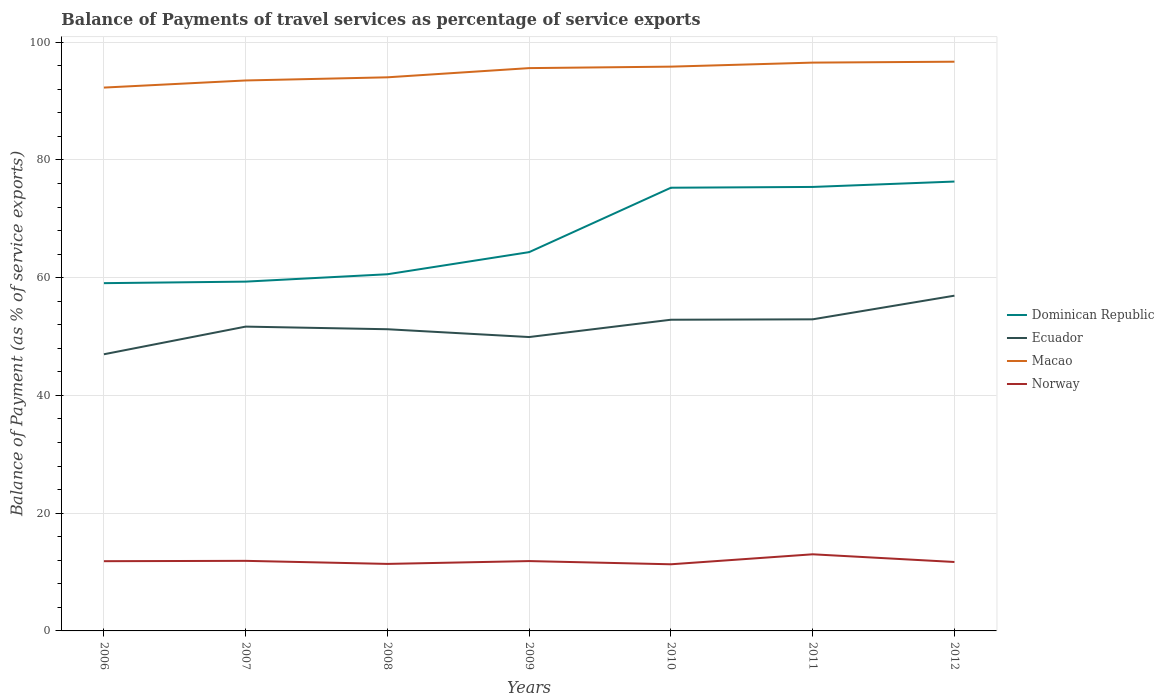Is the number of lines equal to the number of legend labels?
Offer a very short reply. Yes. Across all years, what is the maximum balance of payments of travel services in Macao?
Give a very brief answer. 92.29. What is the total balance of payments of travel services in Ecuador in the graph?
Keep it short and to the point. -5.25. What is the difference between the highest and the second highest balance of payments of travel services in Dominican Republic?
Your answer should be compact. 17.26. What is the difference between the highest and the lowest balance of payments of travel services in Norway?
Offer a very short reply. 3. Is the balance of payments of travel services in Ecuador strictly greater than the balance of payments of travel services in Dominican Republic over the years?
Ensure brevity in your answer.  Yes. How many years are there in the graph?
Make the answer very short. 7. Does the graph contain any zero values?
Make the answer very short. No. Where does the legend appear in the graph?
Your response must be concise. Center right. How many legend labels are there?
Your answer should be compact. 4. What is the title of the graph?
Your answer should be very brief. Balance of Payments of travel services as percentage of service exports. What is the label or title of the Y-axis?
Ensure brevity in your answer.  Balance of Payment (as % of service exports). What is the Balance of Payment (as % of service exports) in Dominican Republic in 2006?
Your answer should be very brief. 59.07. What is the Balance of Payment (as % of service exports) of Ecuador in 2006?
Offer a very short reply. 46.99. What is the Balance of Payment (as % of service exports) in Macao in 2006?
Make the answer very short. 92.29. What is the Balance of Payment (as % of service exports) of Norway in 2006?
Provide a short and direct response. 11.84. What is the Balance of Payment (as % of service exports) in Dominican Republic in 2007?
Ensure brevity in your answer.  59.33. What is the Balance of Payment (as % of service exports) of Ecuador in 2007?
Ensure brevity in your answer.  51.69. What is the Balance of Payment (as % of service exports) of Macao in 2007?
Make the answer very short. 93.5. What is the Balance of Payment (as % of service exports) in Norway in 2007?
Provide a short and direct response. 11.9. What is the Balance of Payment (as % of service exports) in Dominican Republic in 2008?
Provide a succinct answer. 60.58. What is the Balance of Payment (as % of service exports) in Ecuador in 2008?
Offer a terse response. 51.24. What is the Balance of Payment (as % of service exports) of Macao in 2008?
Provide a succinct answer. 94.03. What is the Balance of Payment (as % of service exports) in Norway in 2008?
Provide a short and direct response. 11.38. What is the Balance of Payment (as % of service exports) of Dominican Republic in 2009?
Offer a terse response. 64.34. What is the Balance of Payment (as % of service exports) of Ecuador in 2009?
Make the answer very short. 49.92. What is the Balance of Payment (as % of service exports) in Macao in 2009?
Offer a very short reply. 95.6. What is the Balance of Payment (as % of service exports) in Norway in 2009?
Provide a short and direct response. 11.86. What is the Balance of Payment (as % of service exports) in Dominican Republic in 2010?
Keep it short and to the point. 75.28. What is the Balance of Payment (as % of service exports) of Ecuador in 2010?
Provide a short and direct response. 52.86. What is the Balance of Payment (as % of service exports) of Macao in 2010?
Make the answer very short. 95.85. What is the Balance of Payment (as % of service exports) in Norway in 2010?
Your response must be concise. 11.32. What is the Balance of Payment (as % of service exports) of Dominican Republic in 2011?
Your response must be concise. 75.41. What is the Balance of Payment (as % of service exports) of Ecuador in 2011?
Give a very brief answer. 52.93. What is the Balance of Payment (as % of service exports) in Macao in 2011?
Make the answer very short. 96.53. What is the Balance of Payment (as % of service exports) of Norway in 2011?
Ensure brevity in your answer.  13.01. What is the Balance of Payment (as % of service exports) in Dominican Republic in 2012?
Give a very brief answer. 76.33. What is the Balance of Payment (as % of service exports) of Ecuador in 2012?
Give a very brief answer. 56.94. What is the Balance of Payment (as % of service exports) in Macao in 2012?
Your answer should be very brief. 96.68. What is the Balance of Payment (as % of service exports) in Norway in 2012?
Offer a very short reply. 11.71. Across all years, what is the maximum Balance of Payment (as % of service exports) in Dominican Republic?
Make the answer very short. 76.33. Across all years, what is the maximum Balance of Payment (as % of service exports) of Ecuador?
Your response must be concise. 56.94. Across all years, what is the maximum Balance of Payment (as % of service exports) in Macao?
Offer a very short reply. 96.68. Across all years, what is the maximum Balance of Payment (as % of service exports) in Norway?
Offer a terse response. 13.01. Across all years, what is the minimum Balance of Payment (as % of service exports) of Dominican Republic?
Ensure brevity in your answer.  59.07. Across all years, what is the minimum Balance of Payment (as % of service exports) in Ecuador?
Give a very brief answer. 46.99. Across all years, what is the minimum Balance of Payment (as % of service exports) of Macao?
Ensure brevity in your answer.  92.29. Across all years, what is the minimum Balance of Payment (as % of service exports) of Norway?
Your answer should be very brief. 11.32. What is the total Balance of Payment (as % of service exports) in Dominican Republic in the graph?
Keep it short and to the point. 470.34. What is the total Balance of Payment (as % of service exports) in Ecuador in the graph?
Ensure brevity in your answer.  362.57. What is the total Balance of Payment (as % of service exports) of Macao in the graph?
Your answer should be compact. 664.48. What is the total Balance of Payment (as % of service exports) in Norway in the graph?
Ensure brevity in your answer.  83.04. What is the difference between the Balance of Payment (as % of service exports) of Dominican Republic in 2006 and that in 2007?
Your answer should be very brief. -0.26. What is the difference between the Balance of Payment (as % of service exports) in Ecuador in 2006 and that in 2007?
Your answer should be compact. -4.7. What is the difference between the Balance of Payment (as % of service exports) in Macao in 2006 and that in 2007?
Your response must be concise. -1.21. What is the difference between the Balance of Payment (as % of service exports) of Norway in 2006 and that in 2007?
Ensure brevity in your answer.  -0.06. What is the difference between the Balance of Payment (as % of service exports) in Dominican Republic in 2006 and that in 2008?
Make the answer very short. -1.51. What is the difference between the Balance of Payment (as % of service exports) in Ecuador in 2006 and that in 2008?
Give a very brief answer. -4.25. What is the difference between the Balance of Payment (as % of service exports) of Macao in 2006 and that in 2008?
Provide a succinct answer. -1.74. What is the difference between the Balance of Payment (as % of service exports) of Norway in 2006 and that in 2008?
Ensure brevity in your answer.  0.46. What is the difference between the Balance of Payment (as % of service exports) of Dominican Republic in 2006 and that in 2009?
Your response must be concise. -5.27. What is the difference between the Balance of Payment (as % of service exports) in Ecuador in 2006 and that in 2009?
Offer a terse response. -2.92. What is the difference between the Balance of Payment (as % of service exports) of Macao in 2006 and that in 2009?
Provide a short and direct response. -3.31. What is the difference between the Balance of Payment (as % of service exports) in Norway in 2006 and that in 2009?
Give a very brief answer. -0.02. What is the difference between the Balance of Payment (as % of service exports) in Dominican Republic in 2006 and that in 2010?
Offer a very short reply. -16.21. What is the difference between the Balance of Payment (as % of service exports) in Ecuador in 2006 and that in 2010?
Your answer should be compact. -5.87. What is the difference between the Balance of Payment (as % of service exports) of Macao in 2006 and that in 2010?
Keep it short and to the point. -3.56. What is the difference between the Balance of Payment (as % of service exports) of Norway in 2006 and that in 2010?
Provide a succinct answer. 0.53. What is the difference between the Balance of Payment (as % of service exports) in Dominican Republic in 2006 and that in 2011?
Your answer should be compact. -16.34. What is the difference between the Balance of Payment (as % of service exports) in Ecuador in 2006 and that in 2011?
Make the answer very short. -5.94. What is the difference between the Balance of Payment (as % of service exports) of Macao in 2006 and that in 2011?
Your answer should be very brief. -4.24. What is the difference between the Balance of Payment (as % of service exports) of Norway in 2006 and that in 2011?
Keep it short and to the point. -1.17. What is the difference between the Balance of Payment (as % of service exports) in Dominican Republic in 2006 and that in 2012?
Offer a very short reply. -17.26. What is the difference between the Balance of Payment (as % of service exports) in Ecuador in 2006 and that in 2012?
Give a very brief answer. -9.95. What is the difference between the Balance of Payment (as % of service exports) of Macao in 2006 and that in 2012?
Provide a short and direct response. -4.4. What is the difference between the Balance of Payment (as % of service exports) in Norway in 2006 and that in 2012?
Provide a succinct answer. 0.13. What is the difference between the Balance of Payment (as % of service exports) of Dominican Republic in 2007 and that in 2008?
Offer a very short reply. -1.25. What is the difference between the Balance of Payment (as % of service exports) in Ecuador in 2007 and that in 2008?
Give a very brief answer. 0.45. What is the difference between the Balance of Payment (as % of service exports) in Macao in 2007 and that in 2008?
Your response must be concise. -0.53. What is the difference between the Balance of Payment (as % of service exports) in Norway in 2007 and that in 2008?
Offer a terse response. 0.52. What is the difference between the Balance of Payment (as % of service exports) in Dominican Republic in 2007 and that in 2009?
Provide a succinct answer. -5.01. What is the difference between the Balance of Payment (as % of service exports) in Ecuador in 2007 and that in 2009?
Ensure brevity in your answer.  1.77. What is the difference between the Balance of Payment (as % of service exports) of Macao in 2007 and that in 2009?
Provide a succinct answer. -2.1. What is the difference between the Balance of Payment (as % of service exports) of Norway in 2007 and that in 2009?
Offer a very short reply. 0.04. What is the difference between the Balance of Payment (as % of service exports) of Dominican Republic in 2007 and that in 2010?
Give a very brief answer. -15.95. What is the difference between the Balance of Payment (as % of service exports) of Ecuador in 2007 and that in 2010?
Your answer should be compact. -1.17. What is the difference between the Balance of Payment (as % of service exports) of Macao in 2007 and that in 2010?
Your answer should be very brief. -2.35. What is the difference between the Balance of Payment (as % of service exports) of Norway in 2007 and that in 2010?
Provide a succinct answer. 0.59. What is the difference between the Balance of Payment (as % of service exports) of Dominican Republic in 2007 and that in 2011?
Your answer should be very brief. -16.08. What is the difference between the Balance of Payment (as % of service exports) of Ecuador in 2007 and that in 2011?
Your response must be concise. -1.24. What is the difference between the Balance of Payment (as % of service exports) of Macao in 2007 and that in 2011?
Make the answer very short. -3.03. What is the difference between the Balance of Payment (as % of service exports) of Norway in 2007 and that in 2011?
Provide a short and direct response. -1.11. What is the difference between the Balance of Payment (as % of service exports) of Dominican Republic in 2007 and that in 2012?
Give a very brief answer. -17. What is the difference between the Balance of Payment (as % of service exports) in Ecuador in 2007 and that in 2012?
Provide a succinct answer. -5.25. What is the difference between the Balance of Payment (as % of service exports) of Macao in 2007 and that in 2012?
Provide a succinct answer. -3.19. What is the difference between the Balance of Payment (as % of service exports) in Norway in 2007 and that in 2012?
Ensure brevity in your answer.  0.19. What is the difference between the Balance of Payment (as % of service exports) of Dominican Republic in 2008 and that in 2009?
Offer a very short reply. -3.76. What is the difference between the Balance of Payment (as % of service exports) of Ecuador in 2008 and that in 2009?
Keep it short and to the point. 1.33. What is the difference between the Balance of Payment (as % of service exports) of Macao in 2008 and that in 2009?
Ensure brevity in your answer.  -1.56. What is the difference between the Balance of Payment (as % of service exports) in Norway in 2008 and that in 2009?
Keep it short and to the point. -0.48. What is the difference between the Balance of Payment (as % of service exports) in Dominican Republic in 2008 and that in 2010?
Give a very brief answer. -14.7. What is the difference between the Balance of Payment (as % of service exports) in Ecuador in 2008 and that in 2010?
Your answer should be compact. -1.61. What is the difference between the Balance of Payment (as % of service exports) in Macao in 2008 and that in 2010?
Provide a short and direct response. -1.81. What is the difference between the Balance of Payment (as % of service exports) of Norway in 2008 and that in 2010?
Your answer should be very brief. 0.07. What is the difference between the Balance of Payment (as % of service exports) of Dominican Republic in 2008 and that in 2011?
Offer a terse response. -14.83. What is the difference between the Balance of Payment (as % of service exports) in Ecuador in 2008 and that in 2011?
Give a very brief answer. -1.68. What is the difference between the Balance of Payment (as % of service exports) of Macao in 2008 and that in 2011?
Your response must be concise. -2.5. What is the difference between the Balance of Payment (as % of service exports) in Norway in 2008 and that in 2011?
Your answer should be compact. -1.63. What is the difference between the Balance of Payment (as % of service exports) in Dominican Republic in 2008 and that in 2012?
Keep it short and to the point. -15.75. What is the difference between the Balance of Payment (as % of service exports) of Ecuador in 2008 and that in 2012?
Offer a very short reply. -5.7. What is the difference between the Balance of Payment (as % of service exports) of Macao in 2008 and that in 2012?
Offer a very short reply. -2.65. What is the difference between the Balance of Payment (as % of service exports) of Norway in 2008 and that in 2012?
Ensure brevity in your answer.  -0.33. What is the difference between the Balance of Payment (as % of service exports) in Dominican Republic in 2009 and that in 2010?
Your answer should be very brief. -10.94. What is the difference between the Balance of Payment (as % of service exports) of Ecuador in 2009 and that in 2010?
Give a very brief answer. -2.94. What is the difference between the Balance of Payment (as % of service exports) of Macao in 2009 and that in 2010?
Provide a succinct answer. -0.25. What is the difference between the Balance of Payment (as % of service exports) of Norway in 2009 and that in 2010?
Your response must be concise. 0.54. What is the difference between the Balance of Payment (as % of service exports) in Dominican Republic in 2009 and that in 2011?
Ensure brevity in your answer.  -11.07. What is the difference between the Balance of Payment (as % of service exports) of Ecuador in 2009 and that in 2011?
Ensure brevity in your answer.  -3.01. What is the difference between the Balance of Payment (as % of service exports) of Macao in 2009 and that in 2011?
Your answer should be very brief. -0.93. What is the difference between the Balance of Payment (as % of service exports) in Norway in 2009 and that in 2011?
Offer a terse response. -1.15. What is the difference between the Balance of Payment (as % of service exports) of Dominican Republic in 2009 and that in 2012?
Provide a short and direct response. -11.99. What is the difference between the Balance of Payment (as % of service exports) in Ecuador in 2009 and that in 2012?
Provide a short and direct response. -7.03. What is the difference between the Balance of Payment (as % of service exports) in Macao in 2009 and that in 2012?
Give a very brief answer. -1.09. What is the difference between the Balance of Payment (as % of service exports) of Norway in 2009 and that in 2012?
Offer a terse response. 0.15. What is the difference between the Balance of Payment (as % of service exports) of Dominican Republic in 2010 and that in 2011?
Provide a succinct answer. -0.13. What is the difference between the Balance of Payment (as % of service exports) of Ecuador in 2010 and that in 2011?
Offer a terse response. -0.07. What is the difference between the Balance of Payment (as % of service exports) in Macao in 2010 and that in 2011?
Give a very brief answer. -0.68. What is the difference between the Balance of Payment (as % of service exports) of Norway in 2010 and that in 2011?
Provide a succinct answer. -1.7. What is the difference between the Balance of Payment (as % of service exports) of Dominican Republic in 2010 and that in 2012?
Make the answer very short. -1.05. What is the difference between the Balance of Payment (as % of service exports) in Ecuador in 2010 and that in 2012?
Ensure brevity in your answer.  -4.09. What is the difference between the Balance of Payment (as % of service exports) in Macao in 2010 and that in 2012?
Your response must be concise. -0.84. What is the difference between the Balance of Payment (as % of service exports) in Norway in 2010 and that in 2012?
Provide a succinct answer. -0.39. What is the difference between the Balance of Payment (as % of service exports) of Dominican Republic in 2011 and that in 2012?
Keep it short and to the point. -0.92. What is the difference between the Balance of Payment (as % of service exports) of Ecuador in 2011 and that in 2012?
Provide a short and direct response. -4.02. What is the difference between the Balance of Payment (as % of service exports) in Macao in 2011 and that in 2012?
Keep it short and to the point. -0.15. What is the difference between the Balance of Payment (as % of service exports) of Norway in 2011 and that in 2012?
Offer a terse response. 1.3. What is the difference between the Balance of Payment (as % of service exports) of Dominican Republic in 2006 and the Balance of Payment (as % of service exports) of Ecuador in 2007?
Ensure brevity in your answer.  7.38. What is the difference between the Balance of Payment (as % of service exports) in Dominican Republic in 2006 and the Balance of Payment (as % of service exports) in Macao in 2007?
Ensure brevity in your answer.  -34.43. What is the difference between the Balance of Payment (as % of service exports) in Dominican Republic in 2006 and the Balance of Payment (as % of service exports) in Norway in 2007?
Your answer should be compact. 47.16. What is the difference between the Balance of Payment (as % of service exports) of Ecuador in 2006 and the Balance of Payment (as % of service exports) of Macao in 2007?
Ensure brevity in your answer.  -46.51. What is the difference between the Balance of Payment (as % of service exports) of Ecuador in 2006 and the Balance of Payment (as % of service exports) of Norway in 2007?
Keep it short and to the point. 35.09. What is the difference between the Balance of Payment (as % of service exports) in Macao in 2006 and the Balance of Payment (as % of service exports) in Norway in 2007?
Your answer should be very brief. 80.39. What is the difference between the Balance of Payment (as % of service exports) in Dominican Republic in 2006 and the Balance of Payment (as % of service exports) in Ecuador in 2008?
Provide a succinct answer. 7.83. What is the difference between the Balance of Payment (as % of service exports) of Dominican Republic in 2006 and the Balance of Payment (as % of service exports) of Macao in 2008?
Keep it short and to the point. -34.96. What is the difference between the Balance of Payment (as % of service exports) of Dominican Republic in 2006 and the Balance of Payment (as % of service exports) of Norway in 2008?
Ensure brevity in your answer.  47.68. What is the difference between the Balance of Payment (as % of service exports) in Ecuador in 2006 and the Balance of Payment (as % of service exports) in Macao in 2008?
Provide a succinct answer. -47.04. What is the difference between the Balance of Payment (as % of service exports) of Ecuador in 2006 and the Balance of Payment (as % of service exports) of Norway in 2008?
Give a very brief answer. 35.61. What is the difference between the Balance of Payment (as % of service exports) of Macao in 2006 and the Balance of Payment (as % of service exports) of Norway in 2008?
Your answer should be very brief. 80.91. What is the difference between the Balance of Payment (as % of service exports) of Dominican Republic in 2006 and the Balance of Payment (as % of service exports) of Ecuador in 2009?
Offer a very short reply. 9.15. What is the difference between the Balance of Payment (as % of service exports) of Dominican Republic in 2006 and the Balance of Payment (as % of service exports) of Macao in 2009?
Make the answer very short. -36.53. What is the difference between the Balance of Payment (as % of service exports) of Dominican Republic in 2006 and the Balance of Payment (as % of service exports) of Norway in 2009?
Provide a short and direct response. 47.21. What is the difference between the Balance of Payment (as % of service exports) of Ecuador in 2006 and the Balance of Payment (as % of service exports) of Macao in 2009?
Make the answer very short. -48.61. What is the difference between the Balance of Payment (as % of service exports) in Ecuador in 2006 and the Balance of Payment (as % of service exports) in Norway in 2009?
Offer a terse response. 35.13. What is the difference between the Balance of Payment (as % of service exports) of Macao in 2006 and the Balance of Payment (as % of service exports) of Norway in 2009?
Make the answer very short. 80.43. What is the difference between the Balance of Payment (as % of service exports) in Dominican Republic in 2006 and the Balance of Payment (as % of service exports) in Ecuador in 2010?
Give a very brief answer. 6.21. What is the difference between the Balance of Payment (as % of service exports) in Dominican Republic in 2006 and the Balance of Payment (as % of service exports) in Macao in 2010?
Your answer should be very brief. -36.78. What is the difference between the Balance of Payment (as % of service exports) in Dominican Republic in 2006 and the Balance of Payment (as % of service exports) in Norway in 2010?
Make the answer very short. 47.75. What is the difference between the Balance of Payment (as % of service exports) of Ecuador in 2006 and the Balance of Payment (as % of service exports) of Macao in 2010?
Offer a very short reply. -48.85. What is the difference between the Balance of Payment (as % of service exports) in Ecuador in 2006 and the Balance of Payment (as % of service exports) in Norway in 2010?
Keep it short and to the point. 35.67. What is the difference between the Balance of Payment (as % of service exports) of Macao in 2006 and the Balance of Payment (as % of service exports) of Norway in 2010?
Make the answer very short. 80.97. What is the difference between the Balance of Payment (as % of service exports) in Dominican Republic in 2006 and the Balance of Payment (as % of service exports) in Ecuador in 2011?
Make the answer very short. 6.14. What is the difference between the Balance of Payment (as % of service exports) of Dominican Republic in 2006 and the Balance of Payment (as % of service exports) of Macao in 2011?
Provide a short and direct response. -37.46. What is the difference between the Balance of Payment (as % of service exports) of Dominican Republic in 2006 and the Balance of Payment (as % of service exports) of Norway in 2011?
Keep it short and to the point. 46.05. What is the difference between the Balance of Payment (as % of service exports) of Ecuador in 2006 and the Balance of Payment (as % of service exports) of Macao in 2011?
Your answer should be compact. -49.54. What is the difference between the Balance of Payment (as % of service exports) of Ecuador in 2006 and the Balance of Payment (as % of service exports) of Norway in 2011?
Provide a short and direct response. 33.98. What is the difference between the Balance of Payment (as % of service exports) of Macao in 2006 and the Balance of Payment (as % of service exports) of Norway in 2011?
Provide a short and direct response. 79.27. What is the difference between the Balance of Payment (as % of service exports) in Dominican Republic in 2006 and the Balance of Payment (as % of service exports) in Ecuador in 2012?
Give a very brief answer. 2.12. What is the difference between the Balance of Payment (as % of service exports) of Dominican Republic in 2006 and the Balance of Payment (as % of service exports) of Macao in 2012?
Your answer should be compact. -37.62. What is the difference between the Balance of Payment (as % of service exports) in Dominican Republic in 2006 and the Balance of Payment (as % of service exports) in Norway in 2012?
Your answer should be compact. 47.36. What is the difference between the Balance of Payment (as % of service exports) in Ecuador in 2006 and the Balance of Payment (as % of service exports) in Macao in 2012?
Your answer should be compact. -49.69. What is the difference between the Balance of Payment (as % of service exports) in Ecuador in 2006 and the Balance of Payment (as % of service exports) in Norway in 2012?
Offer a terse response. 35.28. What is the difference between the Balance of Payment (as % of service exports) in Macao in 2006 and the Balance of Payment (as % of service exports) in Norway in 2012?
Make the answer very short. 80.58. What is the difference between the Balance of Payment (as % of service exports) in Dominican Republic in 2007 and the Balance of Payment (as % of service exports) in Ecuador in 2008?
Your response must be concise. 8.09. What is the difference between the Balance of Payment (as % of service exports) in Dominican Republic in 2007 and the Balance of Payment (as % of service exports) in Macao in 2008?
Give a very brief answer. -34.7. What is the difference between the Balance of Payment (as % of service exports) of Dominican Republic in 2007 and the Balance of Payment (as % of service exports) of Norway in 2008?
Your answer should be very brief. 47.94. What is the difference between the Balance of Payment (as % of service exports) in Ecuador in 2007 and the Balance of Payment (as % of service exports) in Macao in 2008?
Ensure brevity in your answer.  -42.34. What is the difference between the Balance of Payment (as % of service exports) of Ecuador in 2007 and the Balance of Payment (as % of service exports) of Norway in 2008?
Offer a terse response. 40.31. What is the difference between the Balance of Payment (as % of service exports) of Macao in 2007 and the Balance of Payment (as % of service exports) of Norway in 2008?
Provide a succinct answer. 82.11. What is the difference between the Balance of Payment (as % of service exports) of Dominican Republic in 2007 and the Balance of Payment (as % of service exports) of Ecuador in 2009?
Make the answer very short. 9.41. What is the difference between the Balance of Payment (as % of service exports) in Dominican Republic in 2007 and the Balance of Payment (as % of service exports) in Macao in 2009?
Your response must be concise. -36.27. What is the difference between the Balance of Payment (as % of service exports) in Dominican Republic in 2007 and the Balance of Payment (as % of service exports) in Norway in 2009?
Your response must be concise. 47.47. What is the difference between the Balance of Payment (as % of service exports) in Ecuador in 2007 and the Balance of Payment (as % of service exports) in Macao in 2009?
Your response must be concise. -43.91. What is the difference between the Balance of Payment (as % of service exports) of Ecuador in 2007 and the Balance of Payment (as % of service exports) of Norway in 2009?
Keep it short and to the point. 39.83. What is the difference between the Balance of Payment (as % of service exports) of Macao in 2007 and the Balance of Payment (as % of service exports) of Norway in 2009?
Keep it short and to the point. 81.63. What is the difference between the Balance of Payment (as % of service exports) of Dominican Republic in 2007 and the Balance of Payment (as % of service exports) of Ecuador in 2010?
Offer a terse response. 6.47. What is the difference between the Balance of Payment (as % of service exports) of Dominican Republic in 2007 and the Balance of Payment (as % of service exports) of Macao in 2010?
Ensure brevity in your answer.  -36.52. What is the difference between the Balance of Payment (as % of service exports) of Dominican Republic in 2007 and the Balance of Payment (as % of service exports) of Norway in 2010?
Offer a very short reply. 48.01. What is the difference between the Balance of Payment (as % of service exports) in Ecuador in 2007 and the Balance of Payment (as % of service exports) in Macao in 2010?
Provide a succinct answer. -44.16. What is the difference between the Balance of Payment (as % of service exports) in Ecuador in 2007 and the Balance of Payment (as % of service exports) in Norway in 2010?
Your answer should be compact. 40.37. What is the difference between the Balance of Payment (as % of service exports) of Macao in 2007 and the Balance of Payment (as % of service exports) of Norway in 2010?
Give a very brief answer. 82.18. What is the difference between the Balance of Payment (as % of service exports) in Dominican Republic in 2007 and the Balance of Payment (as % of service exports) in Ecuador in 2011?
Your response must be concise. 6.4. What is the difference between the Balance of Payment (as % of service exports) in Dominican Republic in 2007 and the Balance of Payment (as % of service exports) in Macao in 2011?
Give a very brief answer. -37.2. What is the difference between the Balance of Payment (as % of service exports) of Dominican Republic in 2007 and the Balance of Payment (as % of service exports) of Norway in 2011?
Your answer should be compact. 46.31. What is the difference between the Balance of Payment (as % of service exports) in Ecuador in 2007 and the Balance of Payment (as % of service exports) in Macao in 2011?
Offer a terse response. -44.84. What is the difference between the Balance of Payment (as % of service exports) in Ecuador in 2007 and the Balance of Payment (as % of service exports) in Norway in 2011?
Give a very brief answer. 38.68. What is the difference between the Balance of Payment (as % of service exports) in Macao in 2007 and the Balance of Payment (as % of service exports) in Norway in 2011?
Provide a short and direct response. 80.48. What is the difference between the Balance of Payment (as % of service exports) of Dominican Republic in 2007 and the Balance of Payment (as % of service exports) of Ecuador in 2012?
Give a very brief answer. 2.38. What is the difference between the Balance of Payment (as % of service exports) in Dominican Republic in 2007 and the Balance of Payment (as % of service exports) in Macao in 2012?
Keep it short and to the point. -37.36. What is the difference between the Balance of Payment (as % of service exports) of Dominican Republic in 2007 and the Balance of Payment (as % of service exports) of Norway in 2012?
Make the answer very short. 47.62. What is the difference between the Balance of Payment (as % of service exports) of Ecuador in 2007 and the Balance of Payment (as % of service exports) of Macao in 2012?
Offer a very short reply. -44.99. What is the difference between the Balance of Payment (as % of service exports) in Ecuador in 2007 and the Balance of Payment (as % of service exports) in Norway in 2012?
Make the answer very short. 39.98. What is the difference between the Balance of Payment (as % of service exports) in Macao in 2007 and the Balance of Payment (as % of service exports) in Norway in 2012?
Ensure brevity in your answer.  81.79. What is the difference between the Balance of Payment (as % of service exports) in Dominican Republic in 2008 and the Balance of Payment (as % of service exports) in Ecuador in 2009?
Offer a very short reply. 10.67. What is the difference between the Balance of Payment (as % of service exports) of Dominican Republic in 2008 and the Balance of Payment (as % of service exports) of Macao in 2009?
Provide a short and direct response. -35.01. What is the difference between the Balance of Payment (as % of service exports) of Dominican Republic in 2008 and the Balance of Payment (as % of service exports) of Norway in 2009?
Keep it short and to the point. 48.72. What is the difference between the Balance of Payment (as % of service exports) of Ecuador in 2008 and the Balance of Payment (as % of service exports) of Macao in 2009?
Give a very brief answer. -44.35. What is the difference between the Balance of Payment (as % of service exports) of Ecuador in 2008 and the Balance of Payment (as % of service exports) of Norway in 2009?
Give a very brief answer. 39.38. What is the difference between the Balance of Payment (as % of service exports) in Macao in 2008 and the Balance of Payment (as % of service exports) in Norway in 2009?
Your answer should be very brief. 82.17. What is the difference between the Balance of Payment (as % of service exports) in Dominican Republic in 2008 and the Balance of Payment (as % of service exports) in Ecuador in 2010?
Ensure brevity in your answer.  7.73. What is the difference between the Balance of Payment (as % of service exports) in Dominican Republic in 2008 and the Balance of Payment (as % of service exports) in Macao in 2010?
Give a very brief answer. -35.26. What is the difference between the Balance of Payment (as % of service exports) in Dominican Republic in 2008 and the Balance of Payment (as % of service exports) in Norway in 2010?
Offer a terse response. 49.26. What is the difference between the Balance of Payment (as % of service exports) of Ecuador in 2008 and the Balance of Payment (as % of service exports) of Macao in 2010?
Ensure brevity in your answer.  -44.6. What is the difference between the Balance of Payment (as % of service exports) in Ecuador in 2008 and the Balance of Payment (as % of service exports) in Norway in 2010?
Your answer should be very brief. 39.92. What is the difference between the Balance of Payment (as % of service exports) of Macao in 2008 and the Balance of Payment (as % of service exports) of Norway in 2010?
Ensure brevity in your answer.  82.71. What is the difference between the Balance of Payment (as % of service exports) of Dominican Republic in 2008 and the Balance of Payment (as % of service exports) of Ecuador in 2011?
Provide a succinct answer. 7.66. What is the difference between the Balance of Payment (as % of service exports) in Dominican Republic in 2008 and the Balance of Payment (as % of service exports) in Macao in 2011?
Your response must be concise. -35.95. What is the difference between the Balance of Payment (as % of service exports) in Dominican Republic in 2008 and the Balance of Payment (as % of service exports) in Norway in 2011?
Make the answer very short. 47.57. What is the difference between the Balance of Payment (as % of service exports) of Ecuador in 2008 and the Balance of Payment (as % of service exports) of Macao in 2011?
Ensure brevity in your answer.  -45.29. What is the difference between the Balance of Payment (as % of service exports) in Ecuador in 2008 and the Balance of Payment (as % of service exports) in Norway in 2011?
Offer a terse response. 38.23. What is the difference between the Balance of Payment (as % of service exports) in Macao in 2008 and the Balance of Payment (as % of service exports) in Norway in 2011?
Provide a succinct answer. 81.02. What is the difference between the Balance of Payment (as % of service exports) in Dominican Republic in 2008 and the Balance of Payment (as % of service exports) in Ecuador in 2012?
Ensure brevity in your answer.  3.64. What is the difference between the Balance of Payment (as % of service exports) of Dominican Republic in 2008 and the Balance of Payment (as % of service exports) of Macao in 2012?
Provide a succinct answer. -36.1. What is the difference between the Balance of Payment (as % of service exports) in Dominican Republic in 2008 and the Balance of Payment (as % of service exports) in Norway in 2012?
Your response must be concise. 48.87. What is the difference between the Balance of Payment (as % of service exports) of Ecuador in 2008 and the Balance of Payment (as % of service exports) of Macao in 2012?
Provide a succinct answer. -45.44. What is the difference between the Balance of Payment (as % of service exports) in Ecuador in 2008 and the Balance of Payment (as % of service exports) in Norway in 2012?
Provide a short and direct response. 39.53. What is the difference between the Balance of Payment (as % of service exports) of Macao in 2008 and the Balance of Payment (as % of service exports) of Norway in 2012?
Offer a very short reply. 82.32. What is the difference between the Balance of Payment (as % of service exports) in Dominican Republic in 2009 and the Balance of Payment (as % of service exports) in Ecuador in 2010?
Offer a very short reply. 11.48. What is the difference between the Balance of Payment (as % of service exports) in Dominican Republic in 2009 and the Balance of Payment (as % of service exports) in Macao in 2010?
Keep it short and to the point. -31.51. What is the difference between the Balance of Payment (as % of service exports) of Dominican Republic in 2009 and the Balance of Payment (as % of service exports) of Norway in 2010?
Make the answer very short. 53.02. What is the difference between the Balance of Payment (as % of service exports) in Ecuador in 2009 and the Balance of Payment (as % of service exports) in Macao in 2010?
Your response must be concise. -45.93. What is the difference between the Balance of Payment (as % of service exports) of Ecuador in 2009 and the Balance of Payment (as % of service exports) of Norway in 2010?
Your answer should be very brief. 38.6. What is the difference between the Balance of Payment (as % of service exports) of Macao in 2009 and the Balance of Payment (as % of service exports) of Norway in 2010?
Your response must be concise. 84.28. What is the difference between the Balance of Payment (as % of service exports) of Dominican Republic in 2009 and the Balance of Payment (as % of service exports) of Ecuador in 2011?
Provide a short and direct response. 11.41. What is the difference between the Balance of Payment (as % of service exports) in Dominican Republic in 2009 and the Balance of Payment (as % of service exports) in Macao in 2011?
Offer a very short reply. -32.19. What is the difference between the Balance of Payment (as % of service exports) of Dominican Republic in 2009 and the Balance of Payment (as % of service exports) of Norway in 2011?
Ensure brevity in your answer.  51.33. What is the difference between the Balance of Payment (as % of service exports) in Ecuador in 2009 and the Balance of Payment (as % of service exports) in Macao in 2011?
Your response must be concise. -46.61. What is the difference between the Balance of Payment (as % of service exports) in Ecuador in 2009 and the Balance of Payment (as % of service exports) in Norway in 2011?
Keep it short and to the point. 36.9. What is the difference between the Balance of Payment (as % of service exports) in Macao in 2009 and the Balance of Payment (as % of service exports) in Norway in 2011?
Offer a very short reply. 82.58. What is the difference between the Balance of Payment (as % of service exports) of Dominican Republic in 2009 and the Balance of Payment (as % of service exports) of Ecuador in 2012?
Your answer should be compact. 7.4. What is the difference between the Balance of Payment (as % of service exports) in Dominican Republic in 2009 and the Balance of Payment (as % of service exports) in Macao in 2012?
Provide a short and direct response. -32.34. What is the difference between the Balance of Payment (as % of service exports) of Dominican Republic in 2009 and the Balance of Payment (as % of service exports) of Norway in 2012?
Your answer should be very brief. 52.63. What is the difference between the Balance of Payment (as % of service exports) of Ecuador in 2009 and the Balance of Payment (as % of service exports) of Macao in 2012?
Ensure brevity in your answer.  -46.77. What is the difference between the Balance of Payment (as % of service exports) of Ecuador in 2009 and the Balance of Payment (as % of service exports) of Norway in 2012?
Provide a succinct answer. 38.21. What is the difference between the Balance of Payment (as % of service exports) in Macao in 2009 and the Balance of Payment (as % of service exports) in Norway in 2012?
Provide a short and direct response. 83.89. What is the difference between the Balance of Payment (as % of service exports) in Dominican Republic in 2010 and the Balance of Payment (as % of service exports) in Ecuador in 2011?
Your response must be concise. 22.35. What is the difference between the Balance of Payment (as % of service exports) of Dominican Republic in 2010 and the Balance of Payment (as % of service exports) of Macao in 2011?
Provide a short and direct response. -21.25. What is the difference between the Balance of Payment (as % of service exports) of Dominican Republic in 2010 and the Balance of Payment (as % of service exports) of Norway in 2011?
Ensure brevity in your answer.  62.27. What is the difference between the Balance of Payment (as % of service exports) of Ecuador in 2010 and the Balance of Payment (as % of service exports) of Macao in 2011?
Offer a terse response. -43.67. What is the difference between the Balance of Payment (as % of service exports) of Ecuador in 2010 and the Balance of Payment (as % of service exports) of Norway in 2011?
Your answer should be compact. 39.84. What is the difference between the Balance of Payment (as % of service exports) in Macao in 2010 and the Balance of Payment (as % of service exports) in Norway in 2011?
Your answer should be very brief. 82.83. What is the difference between the Balance of Payment (as % of service exports) in Dominican Republic in 2010 and the Balance of Payment (as % of service exports) in Ecuador in 2012?
Ensure brevity in your answer.  18.34. What is the difference between the Balance of Payment (as % of service exports) in Dominican Republic in 2010 and the Balance of Payment (as % of service exports) in Macao in 2012?
Give a very brief answer. -21.4. What is the difference between the Balance of Payment (as % of service exports) of Dominican Republic in 2010 and the Balance of Payment (as % of service exports) of Norway in 2012?
Give a very brief answer. 63.57. What is the difference between the Balance of Payment (as % of service exports) of Ecuador in 2010 and the Balance of Payment (as % of service exports) of Macao in 2012?
Your response must be concise. -43.83. What is the difference between the Balance of Payment (as % of service exports) in Ecuador in 2010 and the Balance of Payment (as % of service exports) in Norway in 2012?
Your response must be concise. 41.15. What is the difference between the Balance of Payment (as % of service exports) in Macao in 2010 and the Balance of Payment (as % of service exports) in Norway in 2012?
Give a very brief answer. 84.14. What is the difference between the Balance of Payment (as % of service exports) in Dominican Republic in 2011 and the Balance of Payment (as % of service exports) in Ecuador in 2012?
Keep it short and to the point. 18.47. What is the difference between the Balance of Payment (as % of service exports) in Dominican Republic in 2011 and the Balance of Payment (as % of service exports) in Macao in 2012?
Offer a terse response. -21.27. What is the difference between the Balance of Payment (as % of service exports) of Dominican Republic in 2011 and the Balance of Payment (as % of service exports) of Norway in 2012?
Ensure brevity in your answer.  63.7. What is the difference between the Balance of Payment (as % of service exports) of Ecuador in 2011 and the Balance of Payment (as % of service exports) of Macao in 2012?
Your answer should be compact. -43.76. What is the difference between the Balance of Payment (as % of service exports) of Ecuador in 2011 and the Balance of Payment (as % of service exports) of Norway in 2012?
Offer a terse response. 41.22. What is the difference between the Balance of Payment (as % of service exports) in Macao in 2011 and the Balance of Payment (as % of service exports) in Norway in 2012?
Your answer should be compact. 84.82. What is the average Balance of Payment (as % of service exports) in Dominican Republic per year?
Make the answer very short. 67.19. What is the average Balance of Payment (as % of service exports) in Ecuador per year?
Provide a succinct answer. 51.8. What is the average Balance of Payment (as % of service exports) in Macao per year?
Offer a very short reply. 94.93. What is the average Balance of Payment (as % of service exports) of Norway per year?
Keep it short and to the point. 11.86. In the year 2006, what is the difference between the Balance of Payment (as % of service exports) of Dominican Republic and Balance of Payment (as % of service exports) of Ecuador?
Keep it short and to the point. 12.08. In the year 2006, what is the difference between the Balance of Payment (as % of service exports) in Dominican Republic and Balance of Payment (as % of service exports) in Macao?
Keep it short and to the point. -33.22. In the year 2006, what is the difference between the Balance of Payment (as % of service exports) in Dominican Republic and Balance of Payment (as % of service exports) in Norway?
Offer a very short reply. 47.22. In the year 2006, what is the difference between the Balance of Payment (as % of service exports) in Ecuador and Balance of Payment (as % of service exports) in Macao?
Offer a terse response. -45.3. In the year 2006, what is the difference between the Balance of Payment (as % of service exports) in Ecuador and Balance of Payment (as % of service exports) in Norway?
Your answer should be compact. 35.15. In the year 2006, what is the difference between the Balance of Payment (as % of service exports) in Macao and Balance of Payment (as % of service exports) in Norway?
Provide a short and direct response. 80.44. In the year 2007, what is the difference between the Balance of Payment (as % of service exports) of Dominican Republic and Balance of Payment (as % of service exports) of Ecuador?
Your answer should be very brief. 7.64. In the year 2007, what is the difference between the Balance of Payment (as % of service exports) of Dominican Republic and Balance of Payment (as % of service exports) of Macao?
Offer a terse response. -34.17. In the year 2007, what is the difference between the Balance of Payment (as % of service exports) in Dominican Republic and Balance of Payment (as % of service exports) in Norway?
Your response must be concise. 47.42. In the year 2007, what is the difference between the Balance of Payment (as % of service exports) in Ecuador and Balance of Payment (as % of service exports) in Macao?
Ensure brevity in your answer.  -41.81. In the year 2007, what is the difference between the Balance of Payment (as % of service exports) in Ecuador and Balance of Payment (as % of service exports) in Norway?
Your response must be concise. 39.79. In the year 2007, what is the difference between the Balance of Payment (as % of service exports) of Macao and Balance of Payment (as % of service exports) of Norway?
Give a very brief answer. 81.59. In the year 2008, what is the difference between the Balance of Payment (as % of service exports) of Dominican Republic and Balance of Payment (as % of service exports) of Ecuador?
Your response must be concise. 9.34. In the year 2008, what is the difference between the Balance of Payment (as % of service exports) in Dominican Republic and Balance of Payment (as % of service exports) in Macao?
Your response must be concise. -33.45. In the year 2008, what is the difference between the Balance of Payment (as % of service exports) of Dominican Republic and Balance of Payment (as % of service exports) of Norway?
Offer a terse response. 49.2. In the year 2008, what is the difference between the Balance of Payment (as % of service exports) in Ecuador and Balance of Payment (as % of service exports) in Macao?
Ensure brevity in your answer.  -42.79. In the year 2008, what is the difference between the Balance of Payment (as % of service exports) in Ecuador and Balance of Payment (as % of service exports) in Norway?
Your answer should be compact. 39.86. In the year 2008, what is the difference between the Balance of Payment (as % of service exports) of Macao and Balance of Payment (as % of service exports) of Norway?
Your response must be concise. 82.65. In the year 2009, what is the difference between the Balance of Payment (as % of service exports) in Dominican Republic and Balance of Payment (as % of service exports) in Ecuador?
Your response must be concise. 14.42. In the year 2009, what is the difference between the Balance of Payment (as % of service exports) in Dominican Republic and Balance of Payment (as % of service exports) in Macao?
Your response must be concise. -31.26. In the year 2009, what is the difference between the Balance of Payment (as % of service exports) of Dominican Republic and Balance of Payment (as % of service exports) of Norway?
Your response must be concise. 52.48. In the year 2009, what is the difference between the Balance of Payment (as % of service exports) of Ecuador and Balance of Payment (as % of service exports) of Macao?
Provide a short and direct response. -45.68. In the year 2009, what is the difference between the Balance of Payment (as % of service exports) of Ecuador and Balance of Payment (as % of service exports) of Norway?
Offer a very short reply. 38.05. In the year 2009, what is the difference between the Balance of Payment (as % of service exports) of Macao and Balance of Payment (as % of service exports) of Norway?
Your response must be concise. 83.73. In the year 2010, what is the difference between the Balance of Payment (as % of service exports) of Dominican Republic and Balance of Payment (as % of service exports) of Ecuador?
Ensure brevity in your answer.  22.42. In the year 2010, what is the difference between the Balance of Payment (as % of service exports) in Dominican Republic and Balance of Payment (as % of service exports) in Macao?
Give a very brief answer. -20.57. In the year 2010, what is the difference between the Balance of Payment (as % of service exports) in Dominican Republic and Balance of Payment (as % of service exports) in Norway?
Offer a terse response. 63.96. In the year 2010, what is the difference between the Balance of Payment (as % of service exports) of Ecuador and Balance of Payment (as % of service exports) of Macao?
Your response must be concise. -42.99. In the year 2010, what is the difference between the Balance of Payment (as % of service exports) in Ecuador and Balance of Payment (as % of service exports) in Norway?
Your answer should be very brief. 41.54. In the year 2010, what is the difference between the Balance of Payment (as % of service exports) of Macao and Balance of Payment (as % of service exports) of Norway?
Offer a terse response. 84.53. In the year 2011, what is the difference between the Balance of Payment (as % of service exports) in Dominican Republic and Balance of Payment (as % of service exports) in Ecuador?
Offer a terse response. 22.48. In the year 2011, what is the difference between the Balance of Payment (as % of service exports) of Dominican Republic and Balance of Payment (as % of service exports) of Macao?
Offer a very short reply. -21.12. In the year 2011, what is the difference between the Balance of Payment (as % of service exports) of Dominican Republic and Balance of Payment (as % of service exports) of Norway?
Provide a short and direct response. 62.4. In the year 2011, what is the difference between the Balance of Payment (as % of service exports) in Ecuador and Balance of Payment (as % of service exports) in Macao?
Your answer should be very brief. -43.6. In the year 2011, what is the difference between the Balance of Payment (as % of service exports) in Ecuador and Balance of Payment (as % of service exports) in Norway?
Provide a succinct answer. 39.91. In the year 2011, what is the difference between the Balance of Payment (as % of service exports) in Macao and Balance of Payment (as % of service exports) in Norway?
Keep it short and to the point. 83.51. In the year 2012, what is the difference between the Balance of Payment (as % of service exports) in Dominican Republic and Balance of Payment (as % of service exports) in Ecuador?
Offer a very short reply. 19.38. In the year 2012, what is the difference between the Balance of Payment (as % of service exports) in Dominican Republic and Balance of Payment (as % of service exports) in Macao?
Your answer should be very brief. -20.36. In the year 2012, what is the difference between the Balance of Payment (as % of service exports) in Dominican Republic and Balance of Payment (as % of service exports) in Norway?
Ensure brevity in your answer.  64.62. In the year 2012, what is the difference between the Balance of Payment (as % of service exports) of Ecuador and Balance of Payment (as % of service exports) of Macao?
Ensure brevity in your answer.  -39.74. In the year 2012, what is the difference between the Balance of Payment (as % of service exports) of Ecuador and Balance of Payment (as % of service exports) of Norway?
Keep it short and to the point. 45.23. In the year 2012, what is the difference between the Balance of Payment (as % of service exports) in Macao and Balance of Payment (as % of service exports) in Norway?
Your response must be concise. 84.97. What is the ratio of the Balance of Payment (as % of service exports) of Ecuador in 2006 to that in 2007?
Offer a very short reply. 0.91. What is the ratio of the Balance of Payment (as % of service exports) in Macao in 2006 to that in 2007?
Your answer should be very brief. 0.99. What is the ratio of the Balance of Payment (as % of service exports) of Norway in 2006 to that in 2007?
Offer a terse response. 0.99. What is the ratio of the Balance of Payment (as % of service exports) in Ecuador in 2006 to that in 2008?
Your answer should be very brief. 0.92. What is the ratio of the Balance of Payment (as % of service exports) in Macao in 2006 to that in 2008?
Keep it short and to the point. 0.98. What is the ratio of the Balance of Payment (as % of service exports) of Norway in 2006 to that in 2008?
Your answer should be compact. 1.04. What is the ratio of the Balance of Payment (as % of service exports) in Dominican Republic in 2006 to that in 2009?
Keep it short and to the point. 0.92. What is the ratio of the Balance of Payment (as % of service exports) in Ecuador in 2006 to that in 2009?
Your answer should be compact. 0.94. What is the ratio of the Balance of Payment (as % of service exports) in Macao in 2006 to that in 2009?
Offer a very short reply. 0.97. What is the ratio of the Balance of Payment (as % of service exports) of Dominican Republic in 2006 to that in 2010?
Keep it short and to the point. 0.78. What is the ratio of the Balance of Payment (as % of service exports) in Ecuador in 2006 to that in 2010?
Provide a short and direct response. 0.89. What is the ratio of the Balance of Payment (as % of service exports) of Macao in 2006 to that in 2010?
Your response must be concise. 0.96. What is the ratio of the Balance of Payment (as % of service exports) in Norway in 2006 to that in 2010?
Make the answer very short. 1.05. What is the ratio of the Balance of Payment (as % of service exports) of Dominican Republic in 2006 to that in 2011?
Keep it short and to the point. 0.78. What is the ratio of the Balance of Payment (as % of service exports) of Ecuador in 2006 to that in 2011?
Keep it short and to the point. 0.89. What is the ratio of the Balance of Payment (as % of service exports) in Macao in 2006 to that in 2011?
Ensure brevity in your answer.  0.96. What is the ratio of the Balance of Payment (as % of service exports) of Norway in 2006 to that in 2011?
Provide a short and direct response. 0.91. What is the ratio of the Balance of Payment (as % of service exports) of Dominican Republic in 2006 to that in 2012?
Provide a succinct answer. 0.77. What is the ratio of the Balance of Payment (as % of service exports) in Ecuador in 2006 to that in 2012?
Give a very brief answer. 0.83. What is the ratio of the Balance of Payment (as % of service exports) of Macao in 2006 to that in 2012?
Offer a terse response. 0.95. What is the ratio of the Balance of Payment (as % of service exports) of Norway in 2006 to that in 2012?
Your response must be concise. 1.01. What is the ratio of the Balance of Payment (as % of service exports) in Dominican Republic in 2007 to that in 2008?
Provide a succinct answer. 0.98. What is the ratio of the Balance of Payment (as % of service exports) in Ecuador in 2007 to that in 2008?
Your answer should be very brief. 1.01. What is the ratio of the Balance of Payment (as % of service exports) in Macao in 2007 to that in 2008?
Your answer should be very brief. 0.99. What is the ratio of the Balance of Payment (as % of service exports) in Norway in 2007 to that in 2008?
Give a very brief answer. 1.05. What is the ratio of the Balance of Payment (as % of service exports) of Dominican Republic in 2007 to that in 2009?
Make the answer very short. 0.92. What is the ratio of the Balance of Payment (as % of service exports) of Ecuador in 2007 to that in 2009?
Your answer should be compact. 1.04. What is the ratio of the Balance of Payment (as % of service exports) of Macao in 2007 to that in 2009?
Your answer should be very brief. 0.98. What is the ratio of the Balance of Payment (as % of service exports) of Norway in 2007 to that in 2009?
Offer a terse response. 1. What is the ratio of the Balance of Payment (as % of service exports) in Dominican Republic in 2007 to that in 2010?
Keep it short and to the point. 0.79. What is the ratio of the Balance of Payment (as % of service exports) of Ecuador in 2007 to that in 2010?
Offer a terse response. 0.98. What is the ratio of the Balance of Payment (as % of service exports) of Macao in 2007 to that in 2010?
Your answer should be very brief. 0.98. What is the ratio of the Balance of Payment (as % of service exports) in Norway in 2007 to that in 2010?
Provide a short and direct response. 1.05. What is the ratio of the Balance of Payment (as % of service exports) in Dominican Republic in 2007 to that in 2011?
Offer a very short reply. 0.79. What is the ratio of the Balance of Payment (as % of service exports) of Ecuador in 2007 to that in 2011?
Your answer should be compact. 0.98. What is the ratio of the Balance of Payment (as % of service exports) of Macao in 2007 to that in 2011?
Make the answer very short. 0.97. What is the ratio of the Balance of Payment (as % of service exports) in Norway in 2007 to that in 2011?
Offer a terse response. 0.91. What is the ratio of the Balance of Payment (as % of service exports) in Dominican Republic in 2007 to that in 2012?
Give a very brief answer. 0.78. What is the ratio of the Balance of Payment (as % of service exports) in Ecuador in 2007 to that in 2012?
Give a very brief answer. 0.91. What is the ratio of the Balance of Payment (as % of service exports) in Norway in 2007 to that in 2012?
Keep it short and to the point. 1.02. What is the ratio of the Balance of Payment (as % of service exports) of Dominican Republic in 2008 to that in 2009?
Ensure brevity in your answer.  0.94. What is the ratio of the Balance of Payment (as % of service exports) in Ecuador in 2008 to that in 2009?
Ensure brevity in your answer.  1.03. What is the ratio of the Balance of Payment (as % of service exports) in Macao in 2008 to that in 2009?
Offer a terse response. 0.98. What is the ratio of the Balance of Payment (as % of service exports) in Norway in 2008 to that in 2009?
Your response must be concise. 0.96. What is the ratio of the Balance of Payment (as % of service exports) in Dominican Republic in 2008 to that in 2010?
Your answer should be very brief. 0.8. What is the ratio of the Balance of Payment (as % of service exports) in Ecuador in 2008 to that in 2010?
Your answer should be very brief. 0.97. What is the ratio of the Balance of Payment (as % of service exports) in Macao in 2008 to that in 2010?
Offer a very short reply. 0.98. What is the ratio of the Balance of Payment (as % of service exports) in Norway in 2008 to that in 2010?
Your response must be concise. 1.01. What is the ratio of the Balance of Payment (as % of service exports) of Dominican Republic in 2008 to that in 2011?
Provide a short and direct response. 0.8. What is the ratio of the Balance of Payment (as % of service exports) of Ecuador in 2008 to that in 2011?
Offer a terse response. 0.97. What is the ratio of the Balance of Payment (as % of service exports) of Macao in 2008 to that in 2011?
Your response must be concise. 0.97. What is the ratio of the Balance of Payment (as % of service exports) of Norway in 2008 to that in 2011?
Your response must be concise. 0.87. What is the ratio of the Balance of Payment (as % of service exports) of Dominican Republic in 2008 to that in 2012?
Offer a very short reply. 0.79. What is the ratio of the Balance of Payment (as % of service exports) in Ecuador in 2008 to that in 2012?
Provide a succinct answer. 0.9. What is the ratio of the Balance of Payment (as % of service exports) in Macao in 2008 to that in 2012?
Offer a terse response. 0.97. What is the ratio of the Balance of Payment (as % of service exports) in Norway in 2008 to that in 2012?
Offer a very short reply. 0.97. What is the ratio of the Balance of Payment (as % of service exports) of Dominican Republic in 2009 to that in 2010?
Keep it short and to the point. 0.85. What is the ratio of the Balance of Payment (as % of service exports) in Ecuador in 2009 to that in 2010?
Provide a succinct answer. 0.94. What is the ratio of the Balance of Payment (as % of service exports) in Macao in 2009 to that in 2010?
Provide a succinct answer. 1. What is the ratio of the Balance of Payment (as % of service exports) in Norway in 2009 to that in 2010?
Offer a very short reply. 1.05. What is the ratio of the Balance of Payment (as % of service exports) of Dominican Republic in 2009 to that in 2011?
Ensure brevity in your answer.  0.85. What is the ratio of the Balance of Payment (as % of service exports) in Ecuador in 2009 to that in 2011?
Give a very brief answer. 0.94. What is the ratio of the Balance of Payment (as % of service exports) in Macao in 2009 to that in 2011?
Give a very brief answer. 0.99. What is the ratio of the Balance of Payment (as % of service exports) in Norway in 2009 to that in 2011?
Provide a succinct answer. 0.91. What is the ratio of the Balance of Payment (as % of service exports) in Dominican Republic in 2009 to that in 2012?
Your response must be concise. 0.84. What is the ratio of the Balance of Payment (as % of service exports) in Ecuador in 2009 to that in 2012?
Make the answer very short. 0.88. What is the ratio of the Balance of Payment (as % of service exports) in Norway in 2009 to that in 2012?
Ensure brevity in your answer.  1.01. What is the ratio of the Balance of Payment (as % of service exports) in Dominican Republic in 2010 to that in 2011?
Give a very brief answer. 1. What is the ratio of the Balance of Payment (as % of service exports) in Ecuador in 2010 to that in 2011?
Offer a very short reply. 1. What is the ratio of the Balance of Payment (as % of service exports) in Macao in 2010 to that in 2011?
Your answer should be compact. 0.99. What is the ratio of the Balance of Payment (as % of service exports) of Norway in 2010 to that in 2011?
Ensure brevity in your answer.  0.87. What is the ratio of the Balance of Payment (as % of service exports) of Dominican Republic in 2010 to that in 2012?
Ensure brevity in your answer.  0.99. What is the ratio of the Balance of Payment (as % of service exports) of Ecuador in 2010 to that in 2012?
Ensure brevity in your answer.  0.93. What is the ratio of the Balance of Payment (as % of service exports) in Norway in 2010 to that in 2012?
Your response must be concise. 0.97. What is the ratio of the Balance of Payment (as % of service exports) in Ecuador in 2011 to that in 2012?
Keep it short and to the point. 0.93. What is the ratio of the Balance of Payment (as % of service exports) in Macao in 2011 to that in 2012?
Your answer should be compact. 1. What is the ratio of the Balance of Payment (as % of service exports) in Norway in 2011 to that in 2012?
Make the answer very short. 1.11. What is the difference between the highest and the second highest Balance of Payment (as % of service exports) in Dominican Republic?
Make the answer very short. 0.92. What is the difference between the highest and the second highest Balance of Payment (as % of service exports) in Ecuador?
Your response must be concise. 4.02. What is the difference between the highest and the second highest Balance of Payment (as % of service exports) in Macao?
Offer a very short reply. 0.15. What is the difference between the highest and the second highest Balance of Payment (as % of service exports) of Norway?
Offer a terse response. 1.11. What is the difference between the highest and the lowest Balance of Payment (as % of service exports) in Dominican Republic?
Your answer should be very brief. 17.26. What is the difference between the highest and the lowest Balance of Payment (as % of service exports) of Ecuador?
Keep it short and to the point. 9.95. What is the difference between the highest and the lowest Balance of Payment (as % of service exports) of Macao?
Ensure brevity in your answer.  4.4. What is the difference between the highest and the lowest Balance of Payment (as % of service exports) in Norway?
Your answer should be compact. 1.7. 